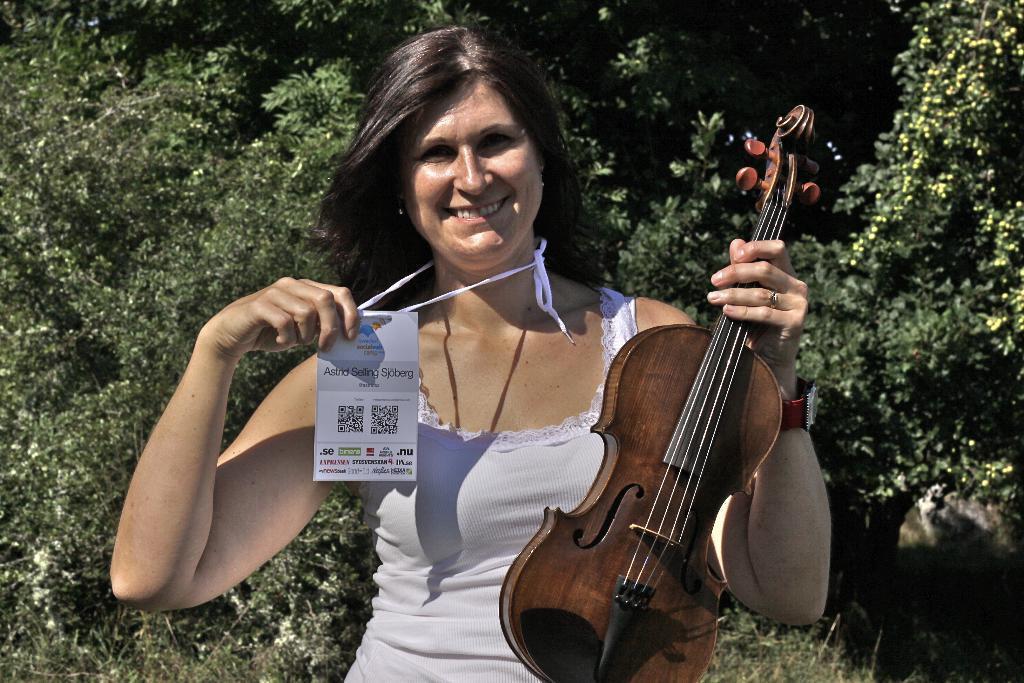Could you give a brief overview of what you see in this image? The picture consists of one woman is standing in white dress and holding a violin in one hand and one card in another hand and behind her there are trees. 